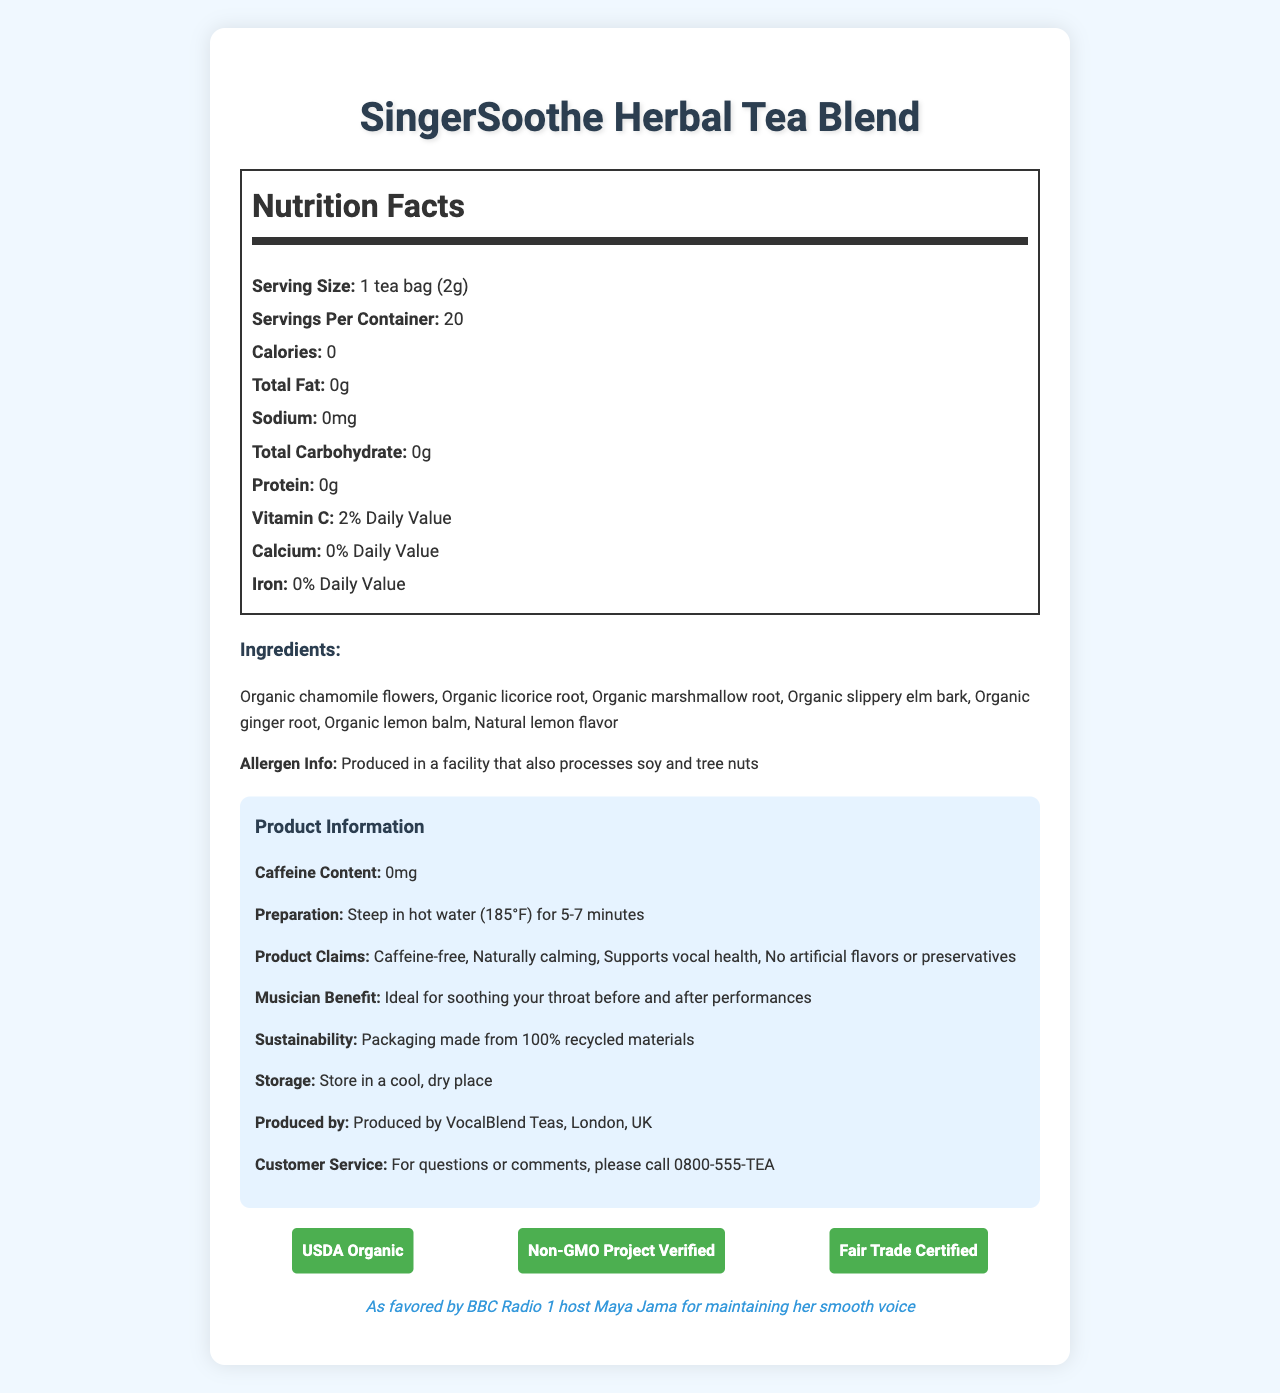what is the serving size? The serving size is explicitly stated in the Nutrition Facts section of the document.
Answer: 1 tea bag (2g) how many servings per container are there? The document lists the number of servings per container in the Nutrition Facts section.
Answer: 20 how many calories are in one serving? The Nutrition Facts indicate that the tea contains 0 calories per serving.
Answer: 0 what herbs are included in the ingredients list? The ingredients list in the document outlines these specific herbs.
Answer: Organic chamomile flowers, Organic licorice root, Organic marshmallow root, Organic slippery elm bark, Organic ginger root, Organic lemon balm, Natural lemon flavor what percentage of Daily Value of Vitamin C does one serving provide? The Nutrition Facts section notes that one serving provides 2% of the Daily Value for Vitamin C.
Answer: 2% is there any caffeine in this herbal tea blend? The document specifies that the caffeine content is 0mg, meaning the tea is caffeine-free.
Answer: No how should you prepare this tea? The preparation instructions provide detailed guidance on how to prepare the tea.
Answer: Steep in hot water (185°F) for 5-7 minutes are there any allergens associated with this product? It is produced in a facility that also processes soy and tree nuts, as mentioned in the allergen information part of the document.
Answer: Yes what is the main benefit for musicians using this tea? The document clearly states that the tea is beneficial for soothing the throat of musicians, particularly before and after performances.
Answer: Ideal for soothing your throat before and after performances which of the following is NOT included in the product claims? A. Caffeine-free B. Supports vocal health C. Contains artificial flavors D. Naturally calming The product claims explicitly state "No artificial flavors or preservatives," making C the correct choice.
Answer: C. Contains artificial flavors where is this product produced? The company information section indicates that the tea is produced by VocalBlend Teas in London, UK.
Answer: London, UK what are the certification labels found on this product? A. USDA Organic B. Non-GMO Project Verified C. Fair Trade Certified D. All of the above The certification section lists all three certifications, making D the correct choice.
Answer: D. All of the above is this tea suitable for vegans? The document does not provide explicit information regarding whether the tea is suitable for vegans.
Answer: Not enough information what is the overall purpose of this document? The document comprehensively covers the product's nutritional facts, ingredients, preparation, benefits for musicians, product claims, and certifications, aiming to inform and promote the tea blend.
Answer: To provide detailed nutritional information, ingredients, preparation instructions, and benefits of the SingerSoothe Herbal Tea Blend, promoting it as a product beneficial for vocal health, particularly for singers like Maya Jama. does this product contain any fat, sodium, or protein? The Nutrition Facts section lists 0g for total fat, sodium, and protein content.
Answer: No what kind of packaging is used for this tea? The sustainability section mentions the packaging's eco-friendly nature.
Answer: Packaging made from 100% recycled materials 